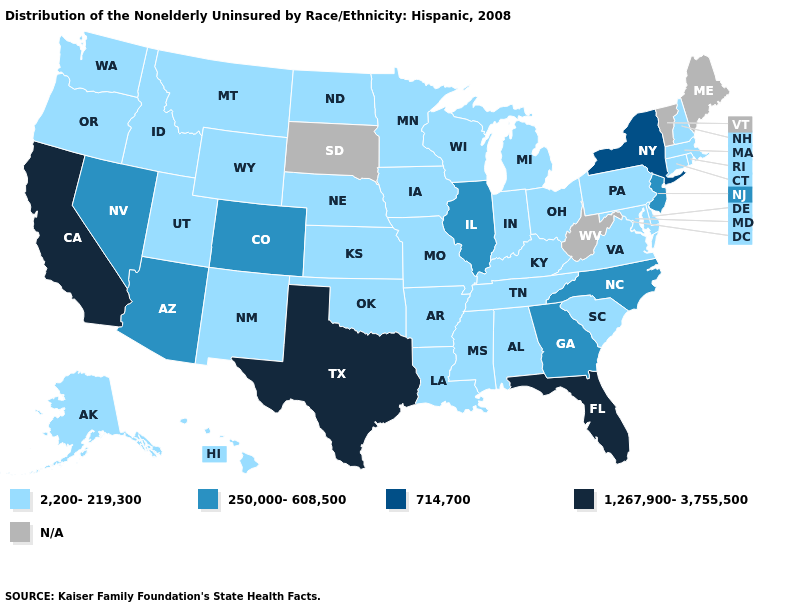What is the highest value in states that border Texas?
Answer briefly. 2,200-219,300. What is the value of Colorado?
Be succinct. 250,000-608,500. What is the value of Wyoming?
Quick response, please. 2,200-219,300. Which states hav the highest value in the South?
Be succinct. Florida, Texas. Does Massachusetts have the lowest value in the Northeast?
Concise answer only. Yes. Name the states that have a value in the range 714,700?
Answer briefly. New York. What is the value of North Dakota?
Give a very brief answer. 2,200-219,300. What is the value of Delaware?
Keep it brief. 2,200-219,300. What is the highest value in the USA?
Quick response, please. 1,267,900-3,755,500. What is the lowest value in the USA?
Give a very brief answer. 2,200-219,300. Name the states that have a value in the range 2,200-219,300?
Be succinct. Alabama, Alaska, Arkansas, Connecticut, Delaware, Hawaii, Idaho, Indiana, Iowa, Kansas, Kentucky, Louisiana, Maryland, Massachusetts, Michigan, Minnesota, Mississippi, Missouri, Montana, Nebraska, New Hampshire, New Mexico, North Dakota, Ohio, Oklahoma, Oregon, Pennsylvania, Rhode Island, South Carolina, Tennessee, Utah, Virginia, Washington, Wisconsin, Wyoming. What is the lowest value in the USA?
Keep it brief. 2,200-219,300. Name the states that have a value in the range 714,700?
Keep it brief. New York. Does the first symbol in the legend represent the smallest category?
Write a very short answer. Yes. 